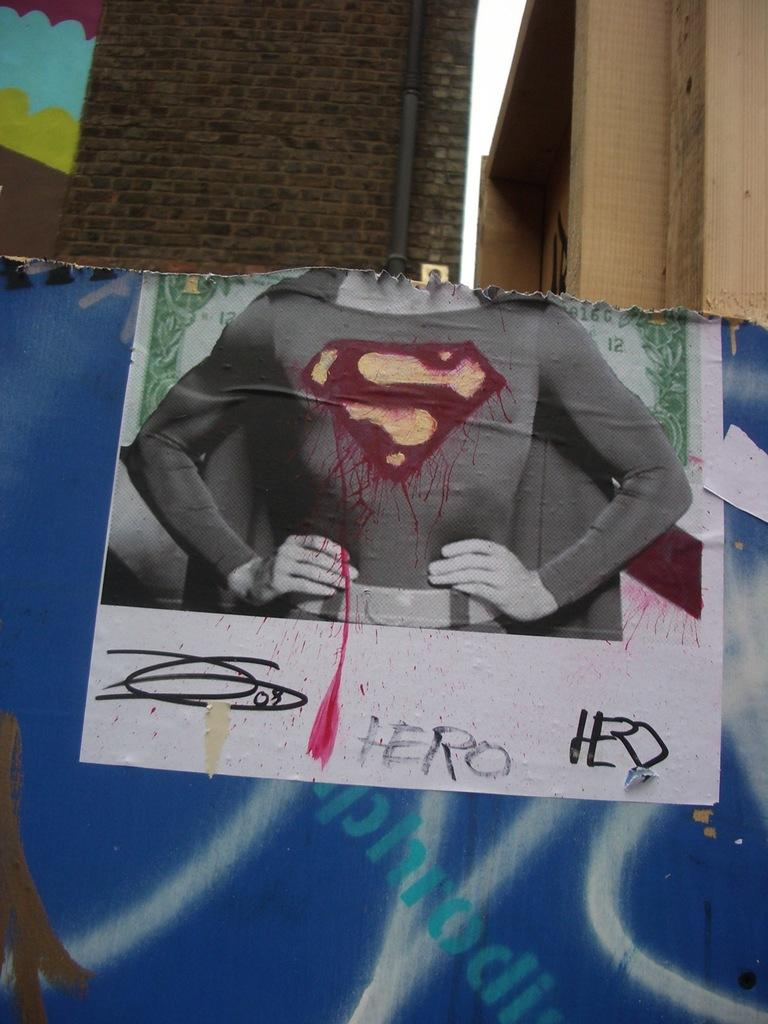What is featured on the poster in the image? The facts do not specify what is on the poster, so we cannot answer this question definitively. What type of structures can be seen in the image? There are buildings in the image. What object is present in the image that is typically used for transporting fluids? There is a pipe in the image. What is visible in the background of the image? The sky is visible in the image. Based on the lighting and visibility, when do you think the image was taken? The image was likely taken during the day, as the sky is visible and the lighting appears bright. How many pages are visible in the image? There are no pages present in the image. What type of self-care activity is being performed in the image? There is no self-care activity depicted in the image. 